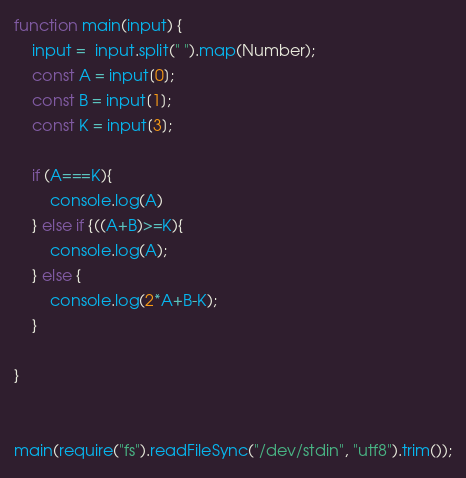<code> <loc_0><loc_0><loc_500><loc_500><_JavaScript_>function main(input) {
	input =  input.split(" ").map(Number);
	const A = input[0];
	const B = input[1];
	const K = input[3];

  	if (A===K){
    	console.log(A)
    } else if {((A+B)>=K){
	    console.log(A);
	} else {
	    console.log(2*A+B-K);
	}

}


main(require("fs").readFileSync("/dev/stdin", "utf8").trim());</code> 